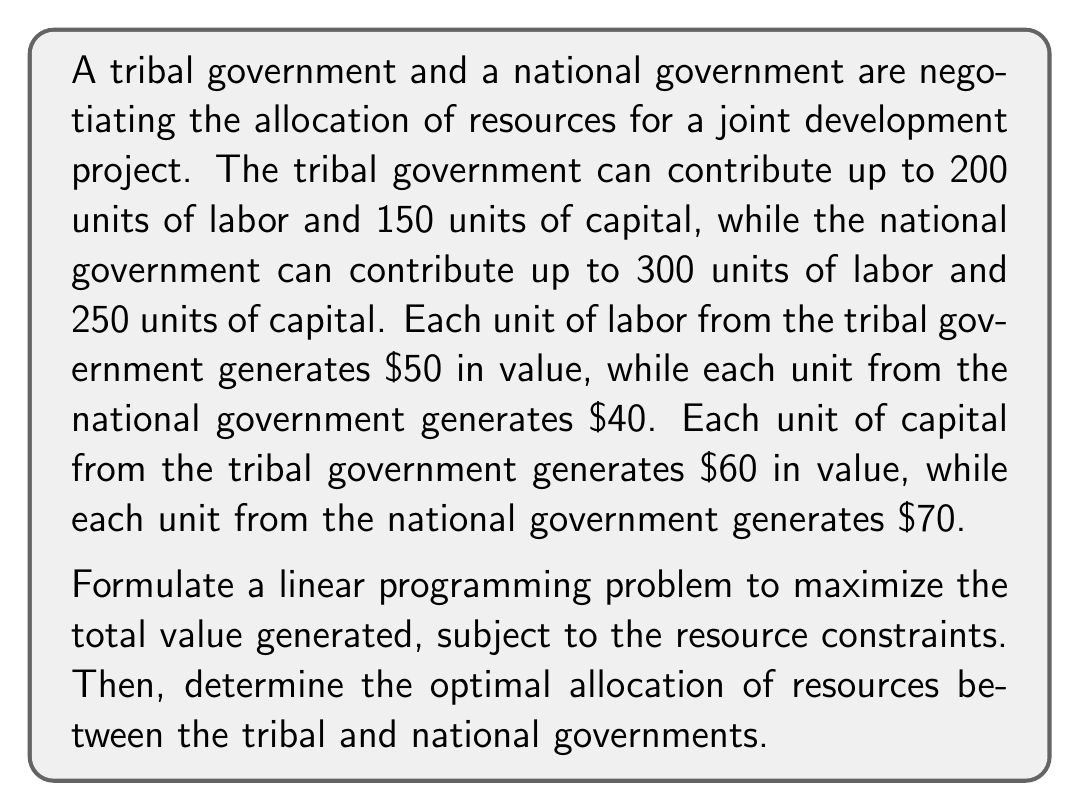Teach me how to tackle this problem. Let's approach this step-by-step:

1) Define variables:
   $x_1$ = units of labor from tribal government
   $x_2$ = units of capital from tribal government
   $x_3$ = units of labor from national government
   $x_4$ = units of capital from national government

2) Objective function:
   Maximize $Z = 50x_1 + 60x_2 + 40x_3 + 70x_4$

3) Constraints:
   Tribal labor: $x_1 \leq 200$
   Tribal capital: $x_2 \leq 150$
   National labor: $x_3 \leq 300$
   National capital: $x_4 \leq 250$
   Non-negativity: $x_1, x_2, x_3, x_4 \geq 0$

4) This is a standard linear programming problem. We can solve it using the simplex method or a linear programming solver. However, we can also observe that each variable contributes independently to the objective function and is only constrained by its upper bound.

5) Therefore, the optimal solution is to use the maximum available of each resource:
   $x_1 = 200$
   $x_2 = 150$
   $x_3 = 300$
   $x_4 = 250$

6) The maximum value generated is:
   $Z = 50(200) + 60(150) + 40(300) + 70(250) = 10,000 + 9,000 + 12,000 + 17,500 = 48,500$

Thus, the optimal allocation is for both governments to contribute all available resources.
Answer: Tribal government: 200 labor, 150 capital; National government: 300 labor, 250 capital; Total value: $48,500 